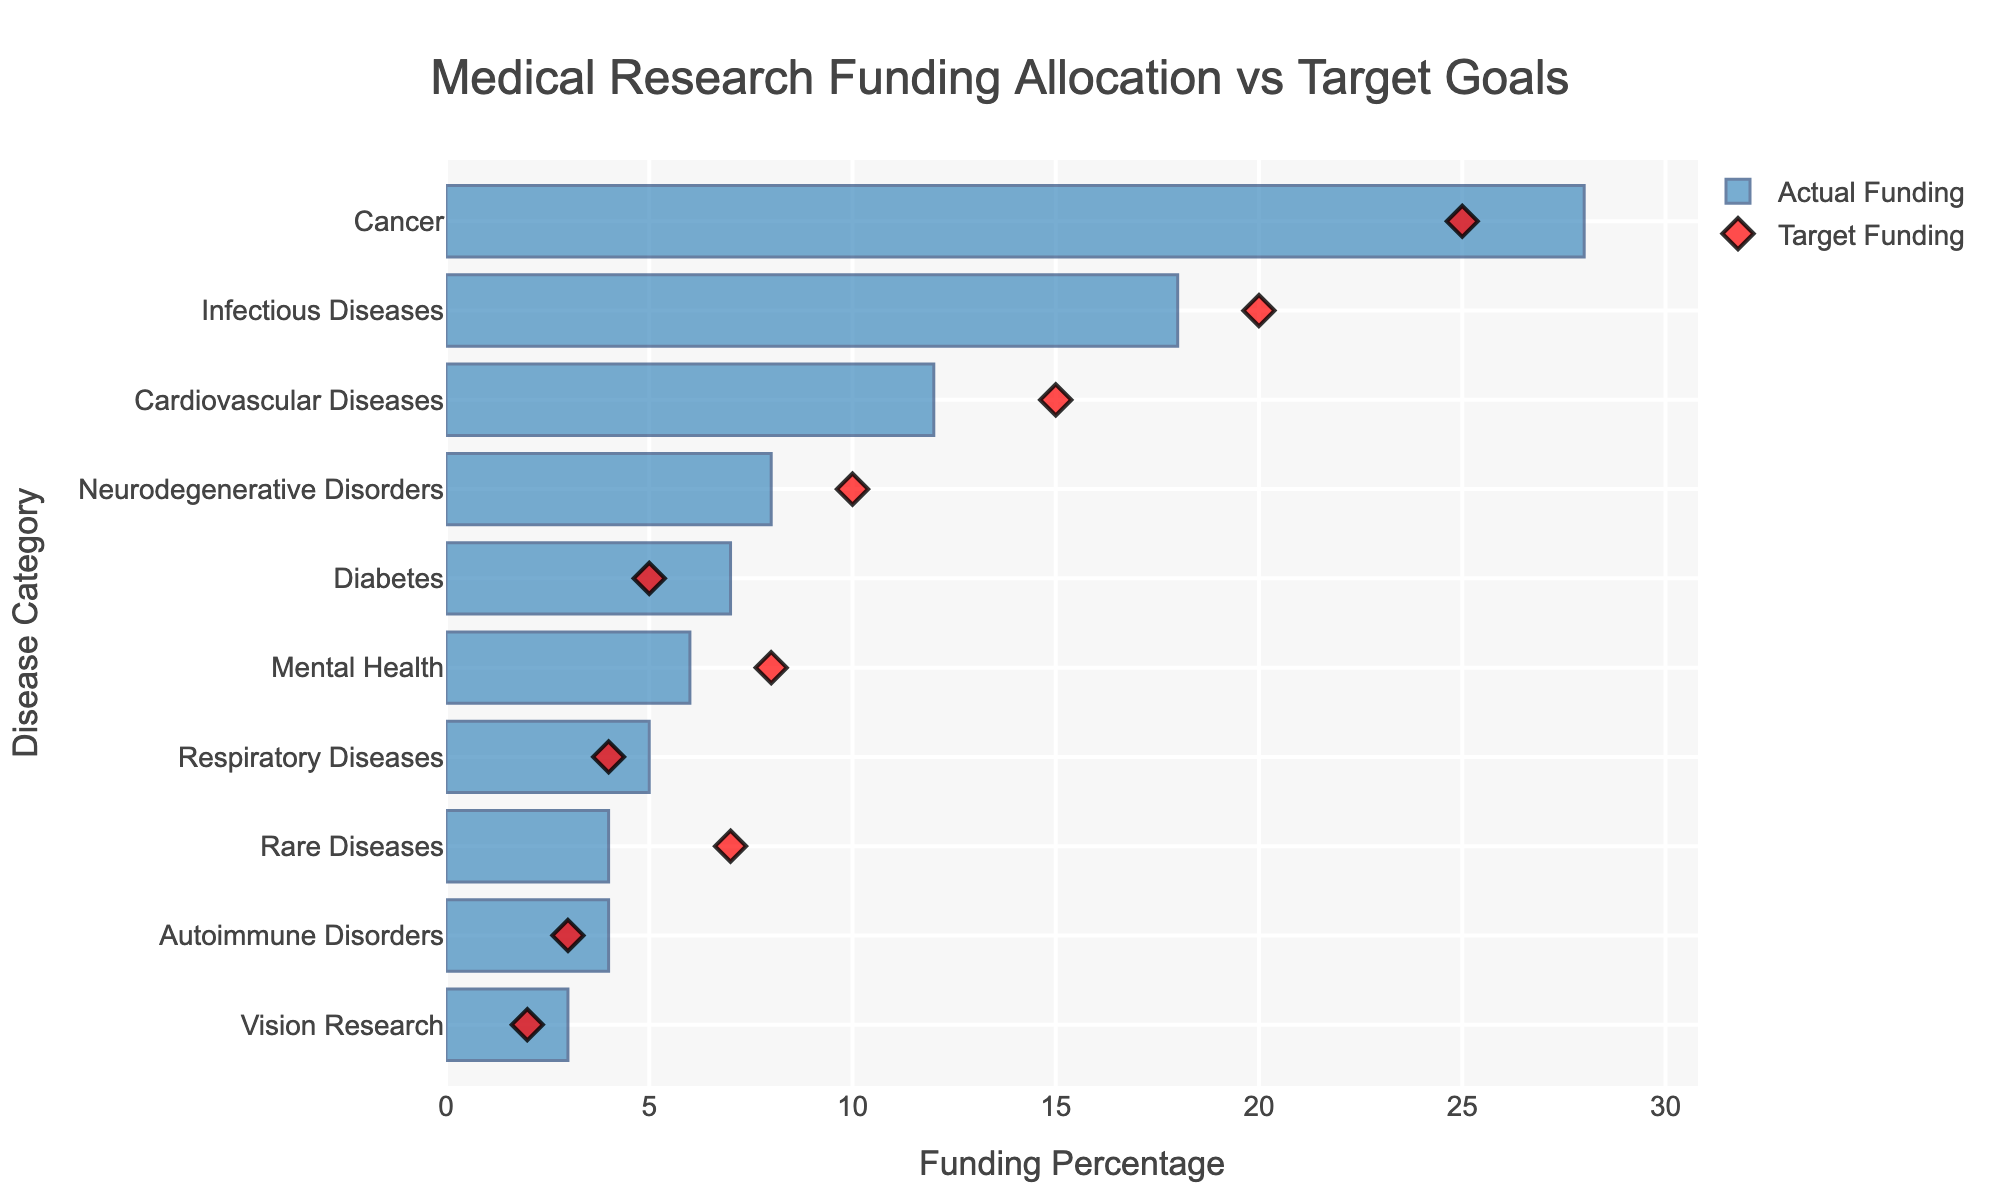What is the title of the chart? The title is visibly placed at the top of the chart and provides a brief description of what the chart represents.
Answer: Medical Research Funding Allocation vs Target Goals Which disease category received the highest percentage of actual funding? By inspecting the bars, the longest bar indicates the highest percentage of actual funding.
Answer: Cancer What is the difference between actual and target funding for Cardiovascular Diseases? Subtract the target funding percentage from the actual funding percentage for Cardiovascular Diseases (12% - 15% = -3%).
Answer: -3% How many disease categories have their actual funding meet or exceed the target funding? Compare the length of each bar with its corresponding marker for all categories; count the ones where the bar is equal to or longer than the marker.
Answer: 4 Which disease category is closest to meeting its target funding percentage? Identify the smallest difference between actual funding and target funding by visually estimating the gaps.
Answer: Respiratory Diseases How does the funding for Neurodegenerative Disorders compare to the funding for Rare Diseases? Compare the bar lengths for both categories; Neurodegenerative Disorders have longer bars.
Answer: Neurodegenerative Disorders have higher actual funding What is the combined actual funding percentage for Mental Health and Diabetes? Add the actual funding percentages for Mental Health and Diabetes (6% + 7%).
Answer: 13% Which disease category has the largest gap between actual and target funding? Find the bar and marker pair with the largest visual gap between them.
Answer: Cancer How many categories have actual funding percentages below 10%? Count the number of bars with lengths representing percentages less than 10%.
Answer: 6 What is the actual funding percentage for Autoimmune Disorders? Locate the bar corresponding to Autoimmune Disorders and read its length value.
Answer: 4% 